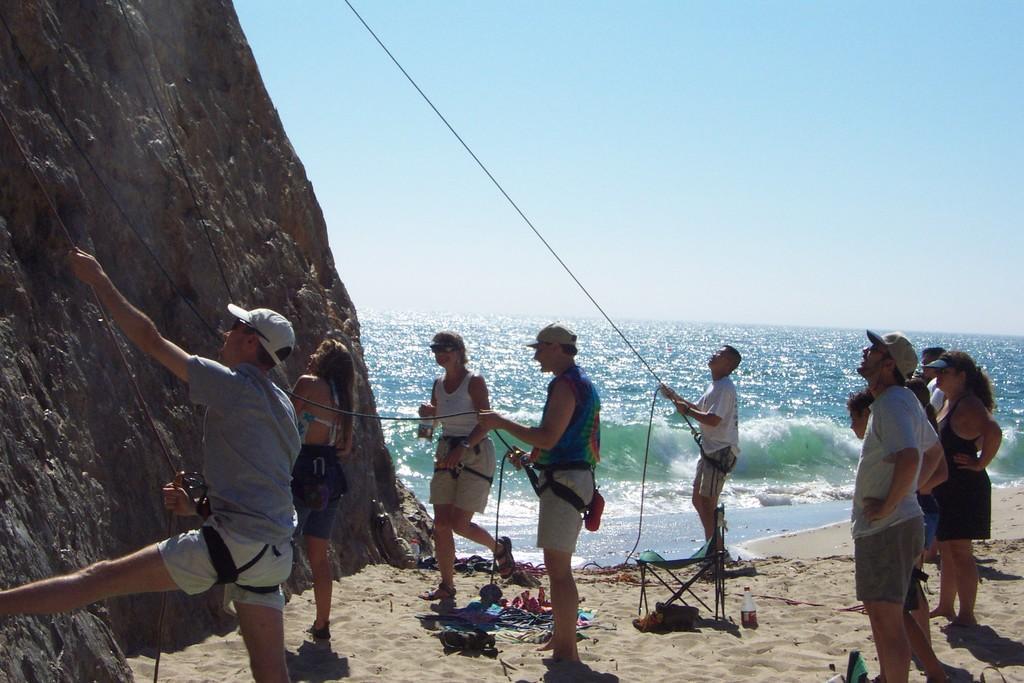Please provide a concise description of this image. On the left side, there are persons in different color dresses, standing on the sand surface. Some of them are holding threads. Beside them, there is a hill. On the right side, there are persons in different color dresses standing on the sand surface. In the background, there are tides of the ocean and there is blue sky. 